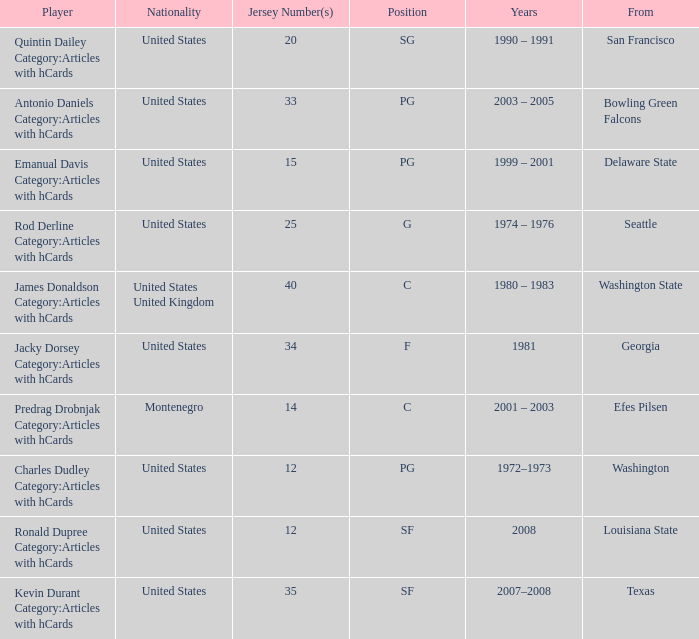What was the nationality of players who held the "g" position? United States. 